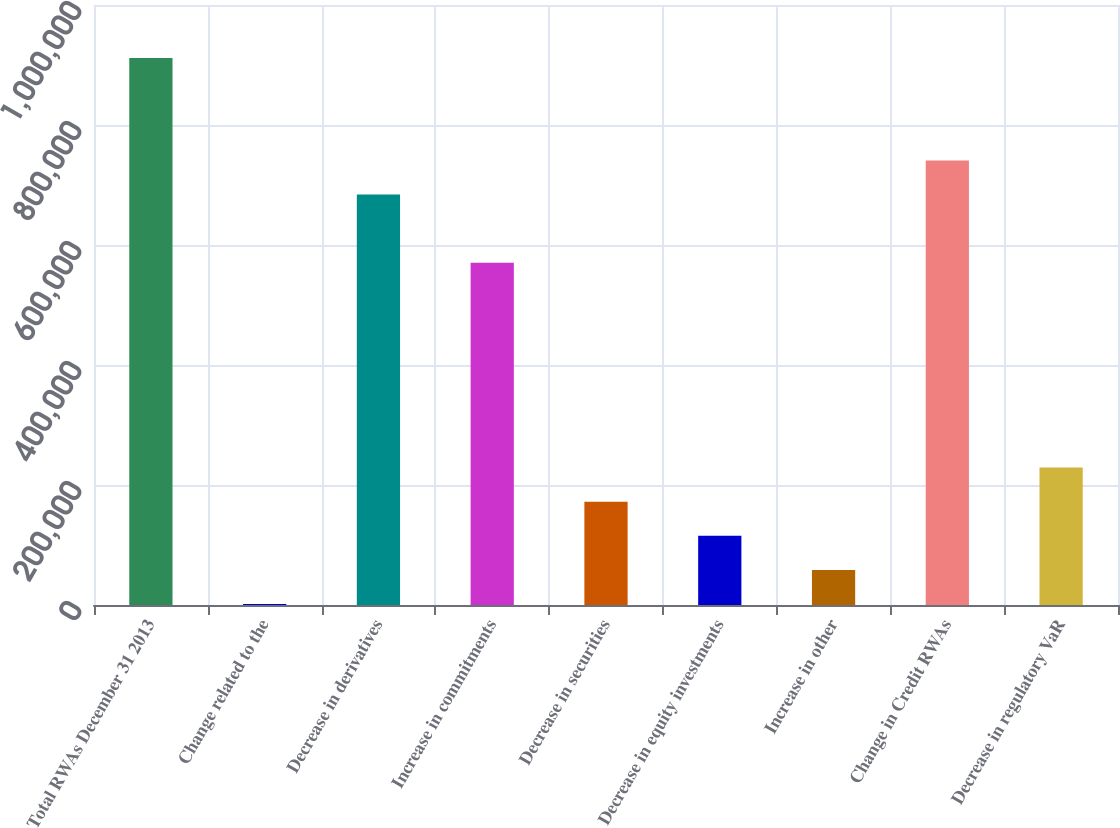Convert chart to OTSL. <chart><loc_0><loc_0><loc_500><loc_500><bar_chart><fcel>Total RWAs December 31 2013<fcel>Change related to the<fcel>Decrease in derivatives<fcel>Increase in commitments<fcel>Decrease in securities<fcel>Decrease in equity investments<fcel>Increase in other<fcel>Change in Credit RWAs<fcel>Decrease in regulatory VaR<nl><fcel>911525<fcel>1626<fcel>684050<fcel>570313<fcel>172232<fcel>115363<fcel>58494.7<fcel>740919<fcel>229101<nl></chart> 